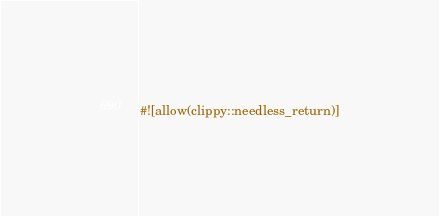Convert code to text. <code><loc_0><loc_0><loc_500><loc_500><_Rust_>#![allow(clippy::needless_return)]
</code> 